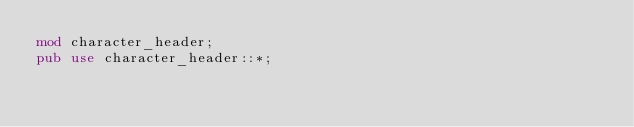<code> <loc_0><loc_0><loc_500><loc_500><_Rust_>mod character_header;
pub use character_header::*;
</code> 